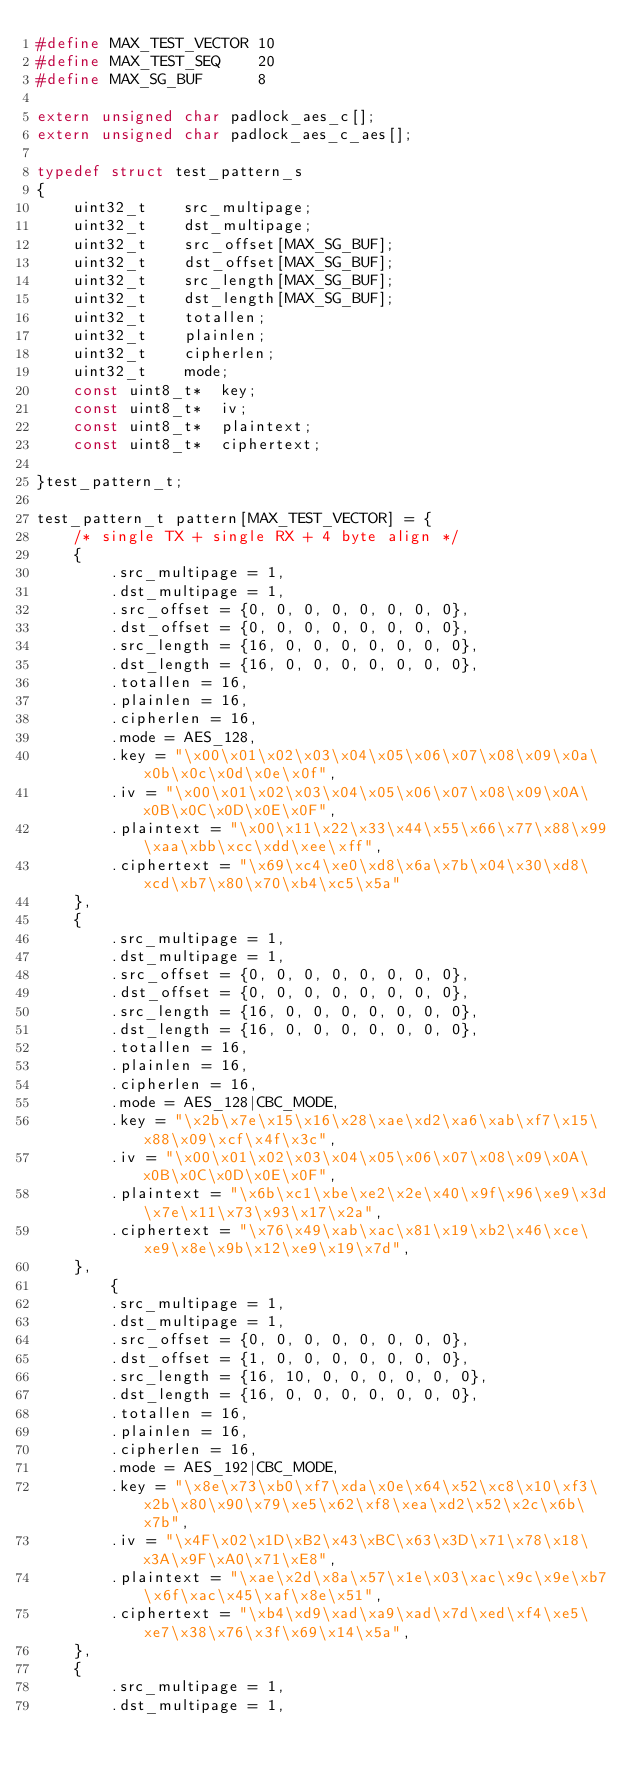Convert code to text. <code><loc_0><loc_0><loc_500><loc_500><_C_>#define MAX_TEST_VECTOR	10
#define MAX_TEST_SEQ	20
#define MAX_SG_BUF		8

extern unsigned char padlock_aes_c[];
extern unsigned char padlock_aes_c_aes[];

typedef struct test_pattern_s
{
	uint32_t	src_multipage;
	uint32_t	dst_multipage;
	uint32_t	src_offset[MAX_SG_BUF];
	uint32_t	dst_offset[MAX_SG_BUF];
	uint32_t	src_length[MAX_SG_BUF];
	uint32_t	dst_length[MAX_SG_BUF];
	uint32_t	totallen;
	uint32_t	plainlen;
	uint32_t	cipherlen;
	uint32_t	mode;
	const uint8_t*	key;
	const uint8_t*	iv;
	const uint8_t*	plaintext;
	const uint8_t*	ciphertext;
		
}test_pattern_t;

test_pattern_t pattern[MAX_TEST_VECTOR] = {
	/* single TX + single RX + 4 byte align */
	{
		.src_multipage = 1,
		.dst_multipage = 1,
		.src_offset = {0, 0, 0, 0, 0, 0, 0, 0},
		.dst_offset = {0, 0, 0, 0, 0, 0, 0, 0},
		.src_length = {16, 0, 0, 0, 0, 0, 0, 0},
		.dst_length = {16, 0, 0, 0, 0, 0, 0, 0},
		.totallen = 16,
		.plainlen = 16,
		.cipherlen = 16,
		.mode = AES_128,
		.key = "\x00\x01\x02\x03\x04\x05\x06\x07\x08\x09\x0a\x0b\x0c\x0d\x0e\x0f",
		.iv = "\x00\x01\x02\x03\x04\x05\x06\x07\x08\x09\x0A\x0B\x0C\x0D\x0E\x0F",
		.plaintext = "\x00\x11\x22\x33\x44\x55\x66\x77\x88\x99\xaa\xbb\xcc\xdd\xee\xff",
		.ciphertext = "\x69\xc4\xe0\xd8\x6a\x7b\x04\x30\xd8\xcd\xb7\x80\x70\xb4\xc5\x5a"
	},
	{
		.src_multipage = 1,
		.dst_multipage = 1,
		.src_offset = {0, 0, 0, 0, 0, 0, 0, 0},
		.dst_offset = {0, 0, 0, 0, 0, 0, 0, 0},
		.src_length = {16, 0, 0, 0, 0, 0, 0, 0},
		.dst_length = {16, 0, 0, 0, 0, 0, 0, 0},
		.totallen = 16,
		.plainlen = 16,
		.cipherlen = 16,
		.mode = AES_128|CBC_MODE,
		.key = "\x2b\x7e\x15\x16\x28\xae\xd2\xa6\xab\xf7\x15\x88\x09\xcf\x4f\x3c",
		.iv = "\x00\x01\x02\x03\x04\x05\x06\x07\x08\x09\x0A\x0B\x0C\x0D\x0E\x0F",
		.plaintext = "\x6b\xc1\xbe\xe2\x2e\x40\x9f\x96\xe9\x3d\x7e\x11\x73\x93\x17\x2a",
		.ciphertext = "\x76\x49\xab\xac\x81\x19\xb2\x46\xce\xe9\x8e\x9b\x12\xe9\x19\x7d",
	},
		{
		.src_multipage = 1,
		.dst_multipage = 1,
		.src_offset = {0, 0, 0, 0, 0, 0, 0, 0},
		.dst_offset = {1, 0, 0, 0, 0, 0, 0, 0},
		.src_length = {16, 10, 0, 0, 0, 0, 0, 0},
		.dst_length = {16, 0, 0, 0, 0, 0, 0, 0},
		.totallen = 16,
		.plainlen = 16,
		.cipherlen = 16,
		.mode = AES_192|CBC_MODE,
		.key = "\x8e\x73\xb0\xf7\xda\x0e\x64\x52\xc8\x10\xf3\x2b\x80\x90\x79\xe5\x62\xf8\xea\xd2\x52\x2c\x6b\x7b",
		.iv = "\x4F\x02\x1D\xB2\x43\xBC\x63\x3D\x71\x78\x18\x3A\x9F\xA0\x71\xE8",
		.plaintext = "\xae\x2d\x8a\x57\x1e\x03\xac\x9c\x9e\xb7\x6f\xac\x45\xaf\x8e\x51",
		.ciphertext = "\xb4\xd9\xad\xa9\xad\x7d\xed\xf4\xe5\xe7\x38\x76\x3f\x69\x14\x5a",
	},
	{
		.src_multipage = 1,
		.dst_multipage = 1,</code> 